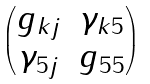Convert formula to latex. <formula><loc_0><loc_0><loc_500><loc_500>\begin{pmatrix} g _ { k j } & \gamma _ { k 5 } \\ \gamma _ { 5 j } & g _ { 5 5 } \end{pmatrix}</formula> 